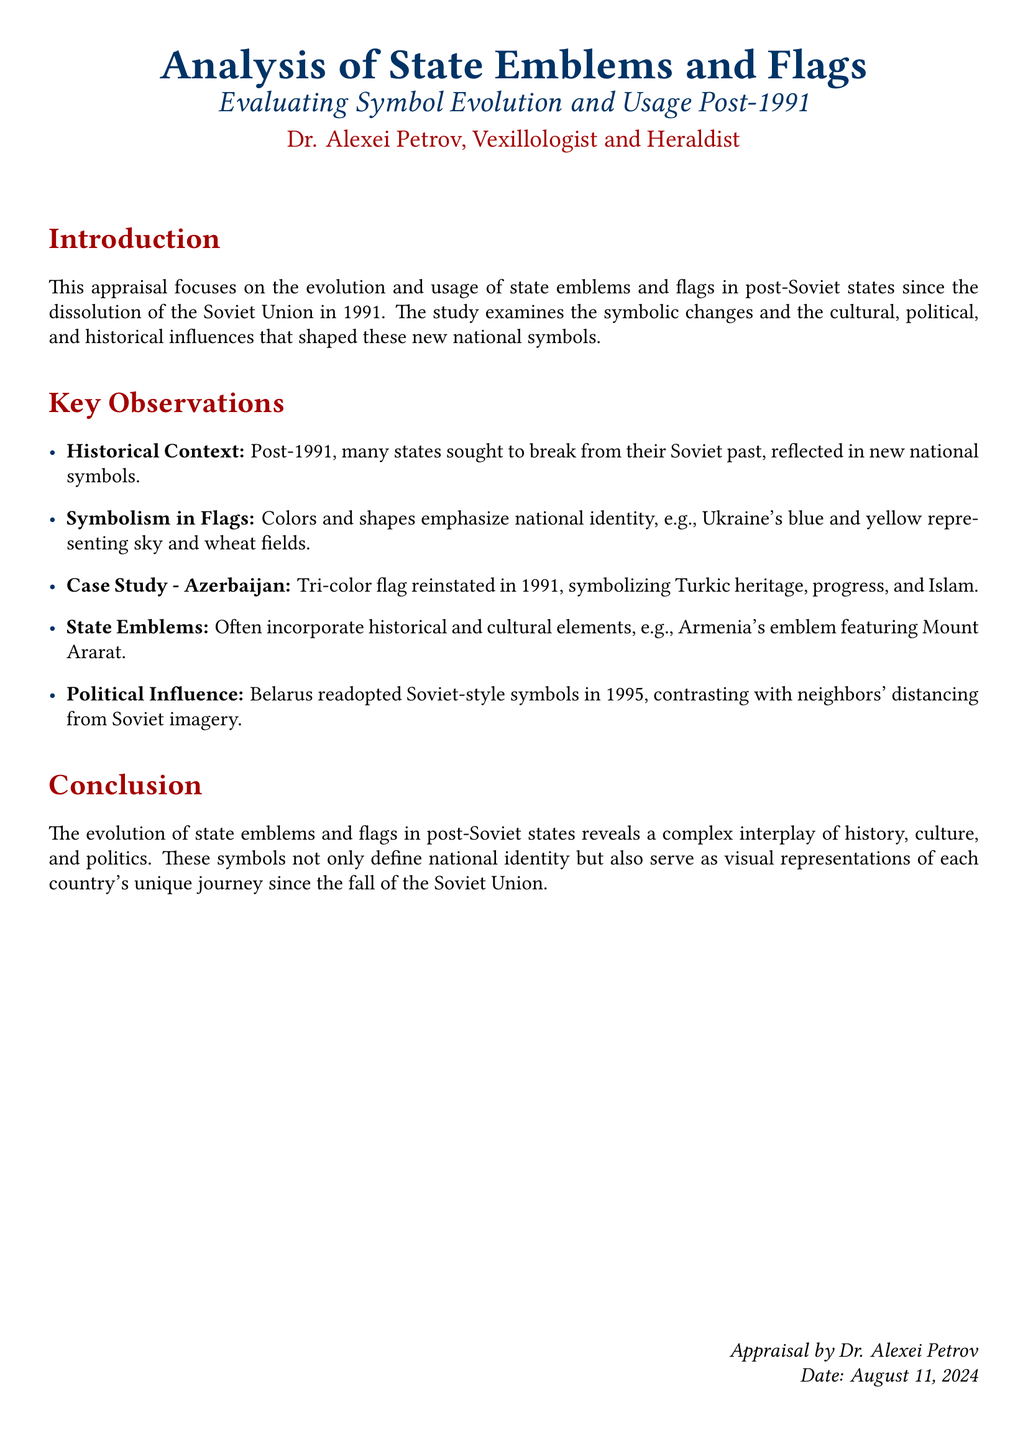What is the main focus of the appraisal? The appraisal focuses on the evolution and usage of state emblems and flags in post-Soviet states since the dissolution of the Soviet Union in 1991.
Answer: evolution and usage of state emblems and flags Who is the author of the appraisal? The author's name is provided at the end of the document, identifying their expertise.
Answer: Dr. Alexei Petrov What color represents Ukraine's national identity? The document describes specific colors representing elements of national identity for several states.
Answer: blue and yellow In which year was Azerbaijan's tri-color flag reinstated? The year is explicitly mentioned as part of the case study on Azerbaijan within the document.
Answer: 1991 What cultural element is incorporated in Armenia's state emblem? The emblem features specific cultural and historical elements that are highlighted in the document.
Answer: Mount Ararat Which country readopted Soviet-style symbols in 1995? One specific country's political choices are noted in comparison to its neighbors.
Answer: Belarus What does the conclusion describe regarding state symbols? The conclusion summarizes the overall function and importance of national symbols post-1991.
Answer: define national identity What date is indicated at the end of the appraisal? The date is automatically generated by the document and reflects when the appraisal was created.
Answer: today's date (current date) 